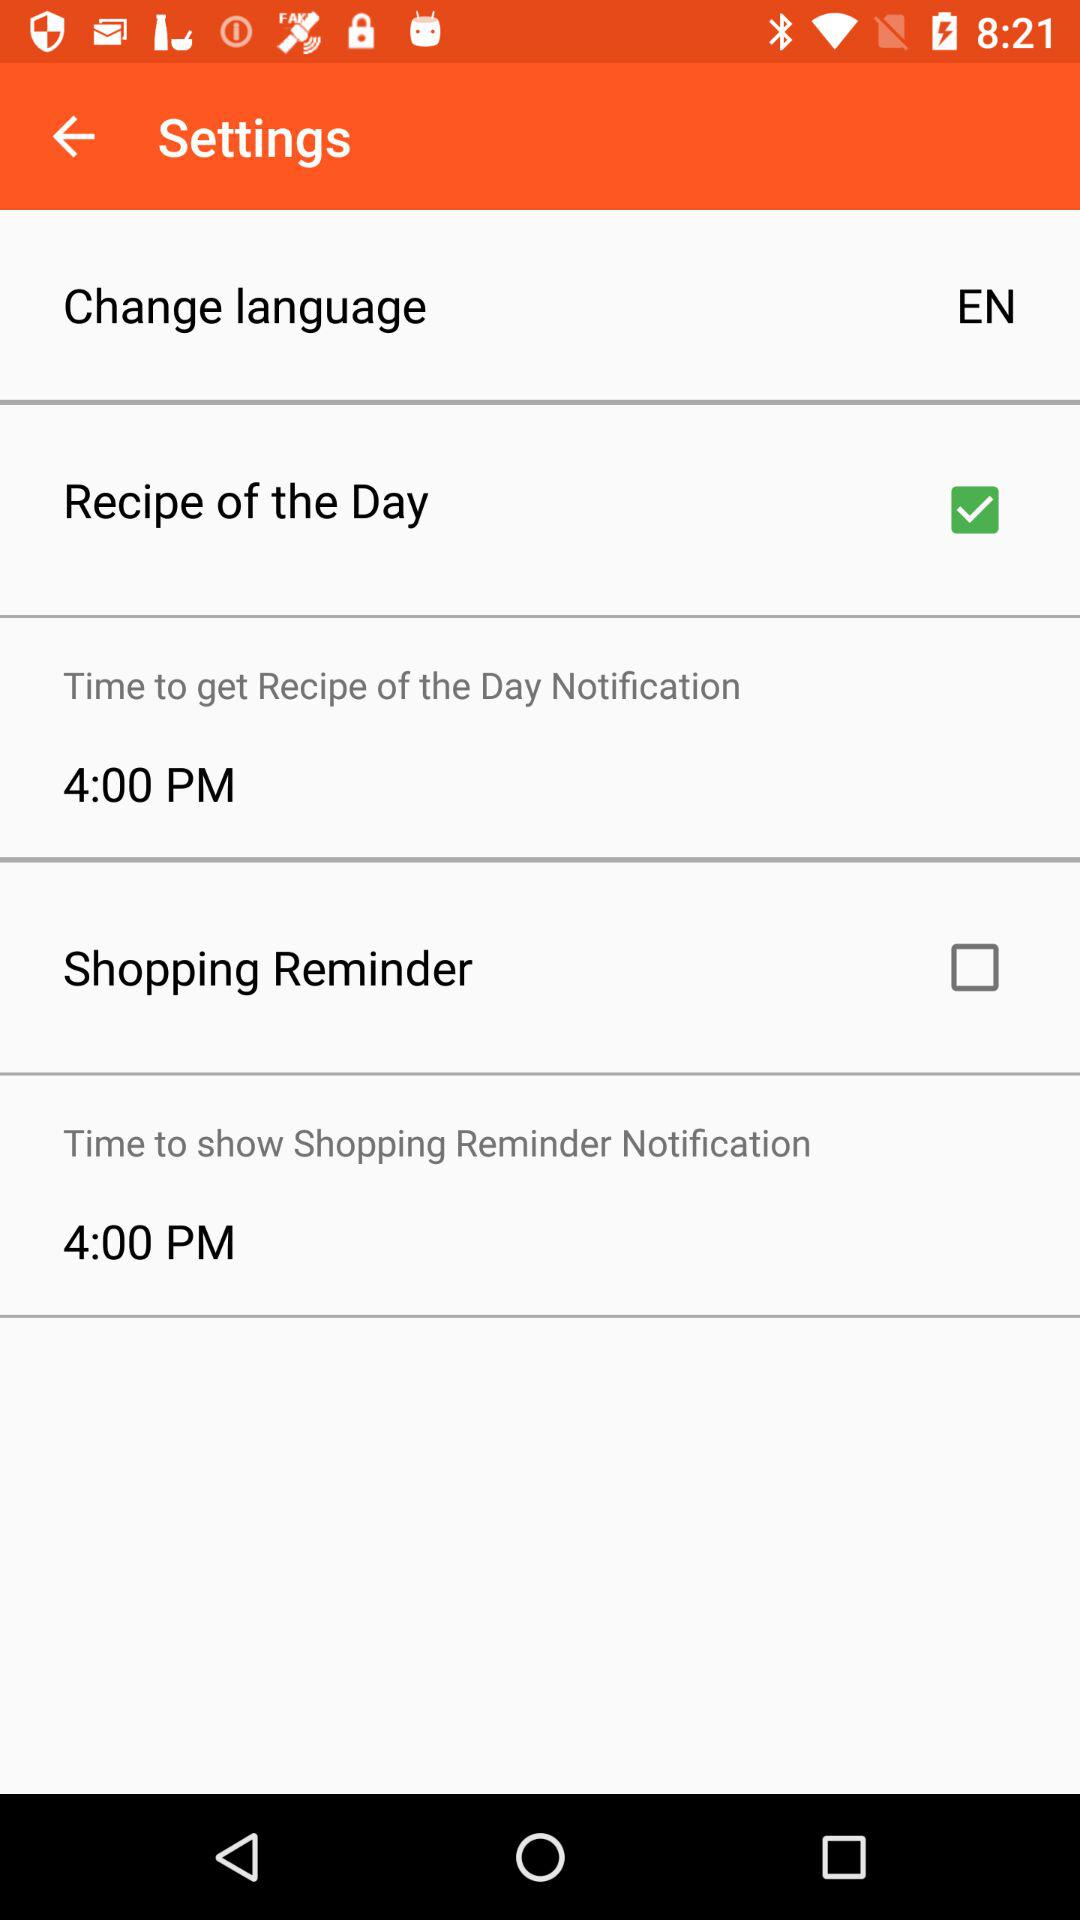Which option is checked? The checked option is "Recipe of the Day". 